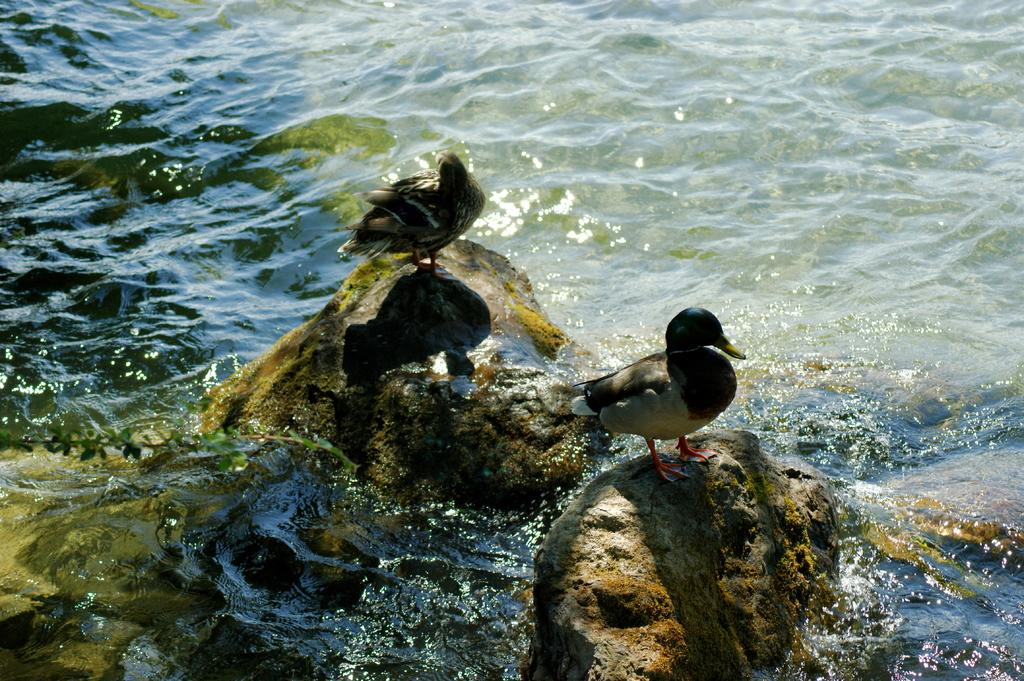What is the primary element in the image? There is water in the image. What objects are present in the water? There are two stones in the water. What animals are standing on the stones? Two ducks are standing on the stones. What colors can be seen on the ducks' beaks? The ducks have a combination of white, black, and yellow on their beaks. What type of spy equipment can be seen in the image? There is no spy equipment present in the image; it features water, stones, and ducks. What type of support system is visible in the image? There is no support system visible in the image; it features water, stones, and ducks. 